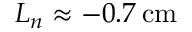<formula> <loc_0><loc_0><loc_500><loc_500>L _ { n } \approx - 0 . 7 \, c m</formula> 